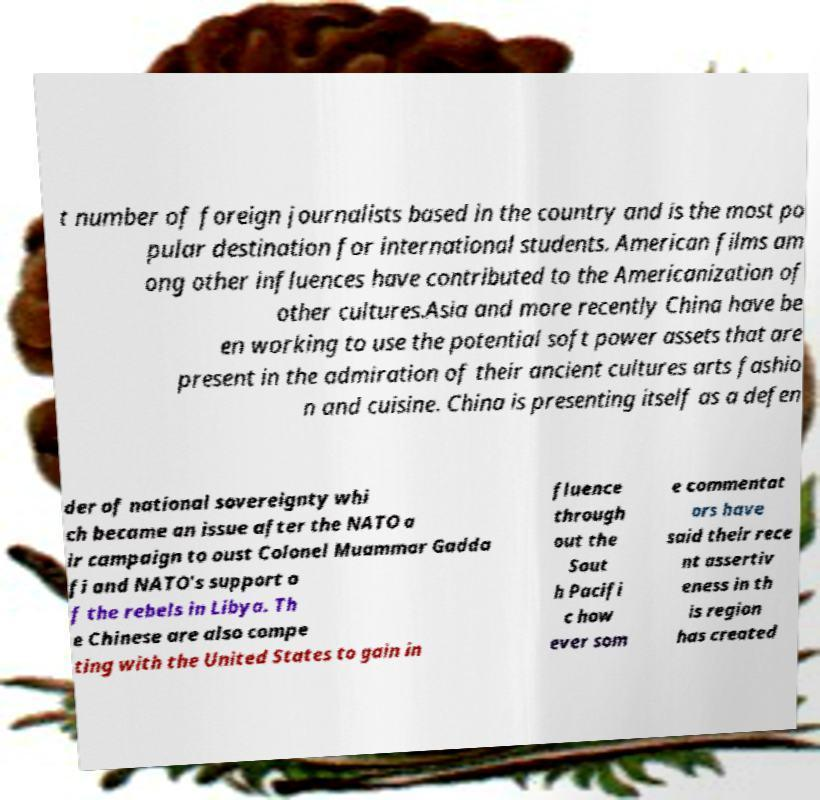Can you accurately transcribe the text from the provided image for me? t number of foreign journalists based in the country and is the most po pular destination for international students. American films am ong other influences have contributed to the Americanization of other cultures.Asia and more recently China have be en working to use the potential soft power assets that are present in the admiration of their ancient cultures arts fashio n and cuisine. China is presenting itself as a defen der of national sovereignty whi ch became an issue after the NATO a ir campaign to oust Colonel Muammar Gadda fi and NATO's support o f the rebels in Libya. Th e Chinese are also compe ting with the United States to gain in fluence through out the Sout h Pacifi c how ever som e commentat ors have said their rece nt assertiv eness in th is region has created 